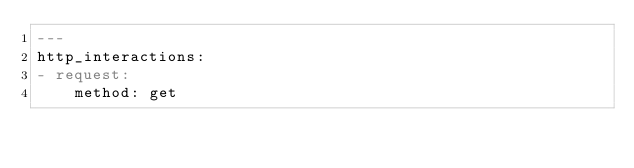Convert code to text. <code><loc_0><loc_0><loc_500><loc_500><_YAML_>---
http_interactions:
- request:
    method: get</code> 